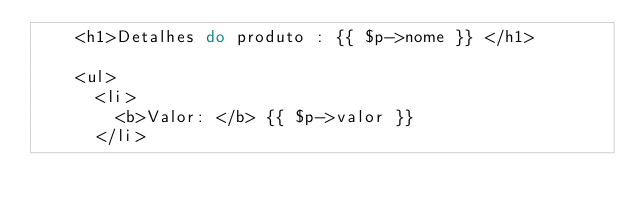<code> <loc_0><loc_0><loc_500><loc_500><_PHP_>    <h1>Detalhes do produto : {{ $p->nome }} </h1>

    <ul>
      <li>
        <b>Valor: </b> {{ $p->valor }}
      </li></code> 